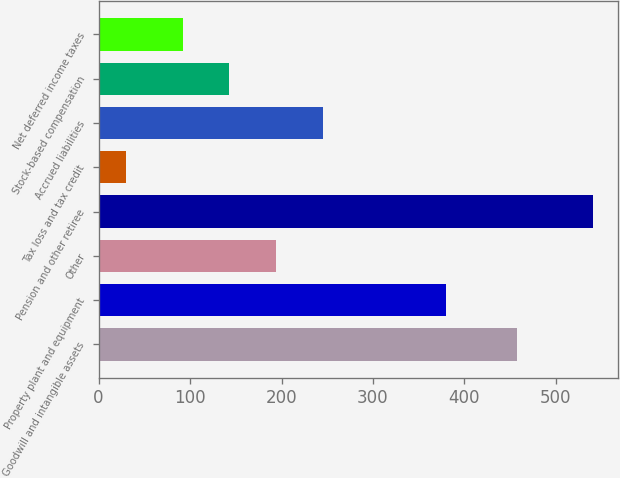Convert chart to OTSL. <chart><loc_0><loc_0><loc_500><loc_500><bar_chart><fcel>Goodwill and intangible assets<fcel>Property plant and equipment<fcel>Other<fcel>Pension and other retiree<fcel>Tax loss and tax credit<fcel>Accrued liabilities<fcel>Stock-based compensation<fcel>Net deferred income taxes<nl><fcel>458<fcel>380<fcel>194.2<fcel>541<fcel>30<fcel>245.3<fcel>143.1<fcel>92<nl></chart> 